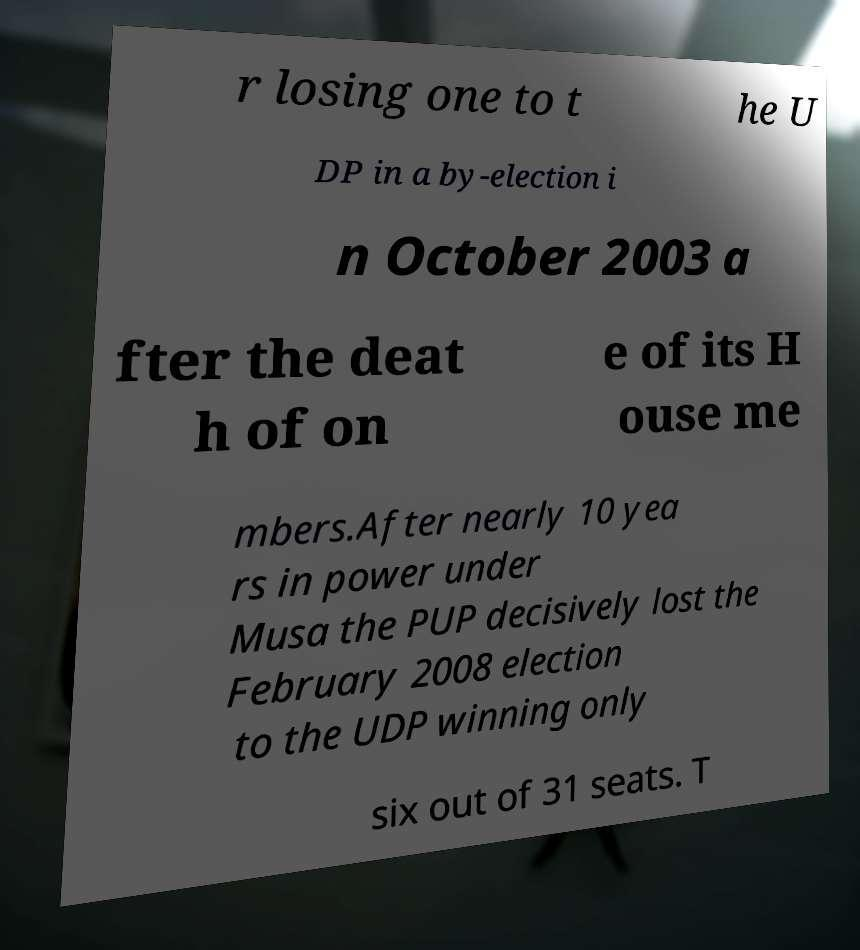Please identify and transcribe the text found in this image. r losing one to t he U DP in a by-election i n October 2003 a fter the deat h of on e of its H ouse me mbers.After nearly 10 yea rs in power under Musa the PUP decisively lost the February 2008 election to the UDP winning only six out of 31 seats. T 